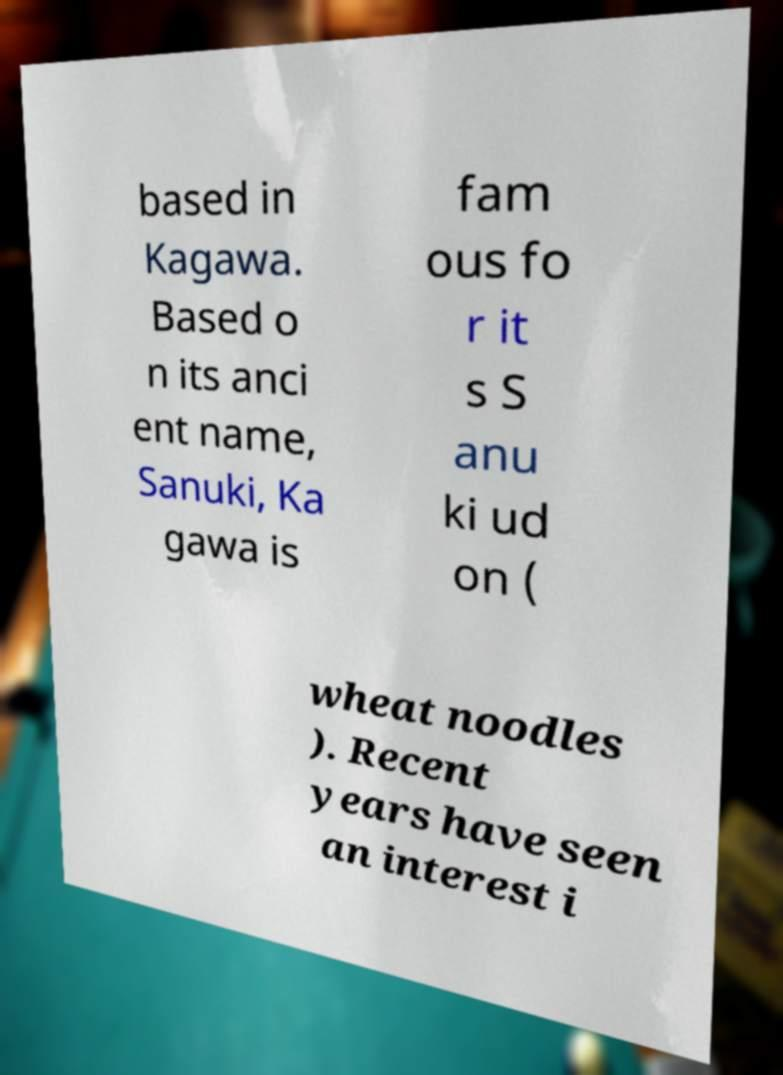Could you assist in decoding the text presented in this image and type it out clearly? based in Kagawa. Based o n its anci ent name, Sanuki, Ka gawa is fam ous fo r it s S anu ki ud on ( wheat noodles ). Recent years have seen an interest i 